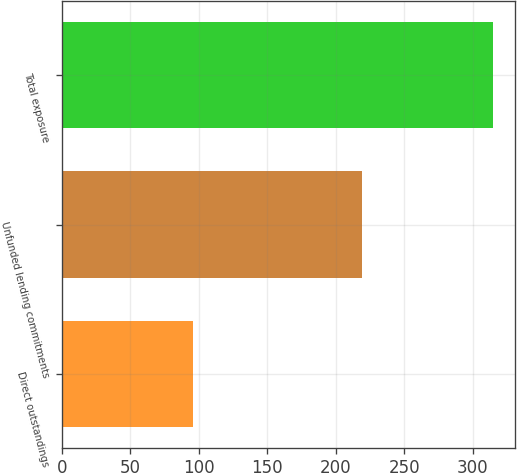Convert chart to OTSL. <chart><loc_0><loc_0><loc_500><loc_500><bar_chart><fcel>Direct outstandings<fcel>Unfunded lending commitments<fcel>Total exposure<nl><fcel>96<fcel>219<fcel>315<nl></chart> 